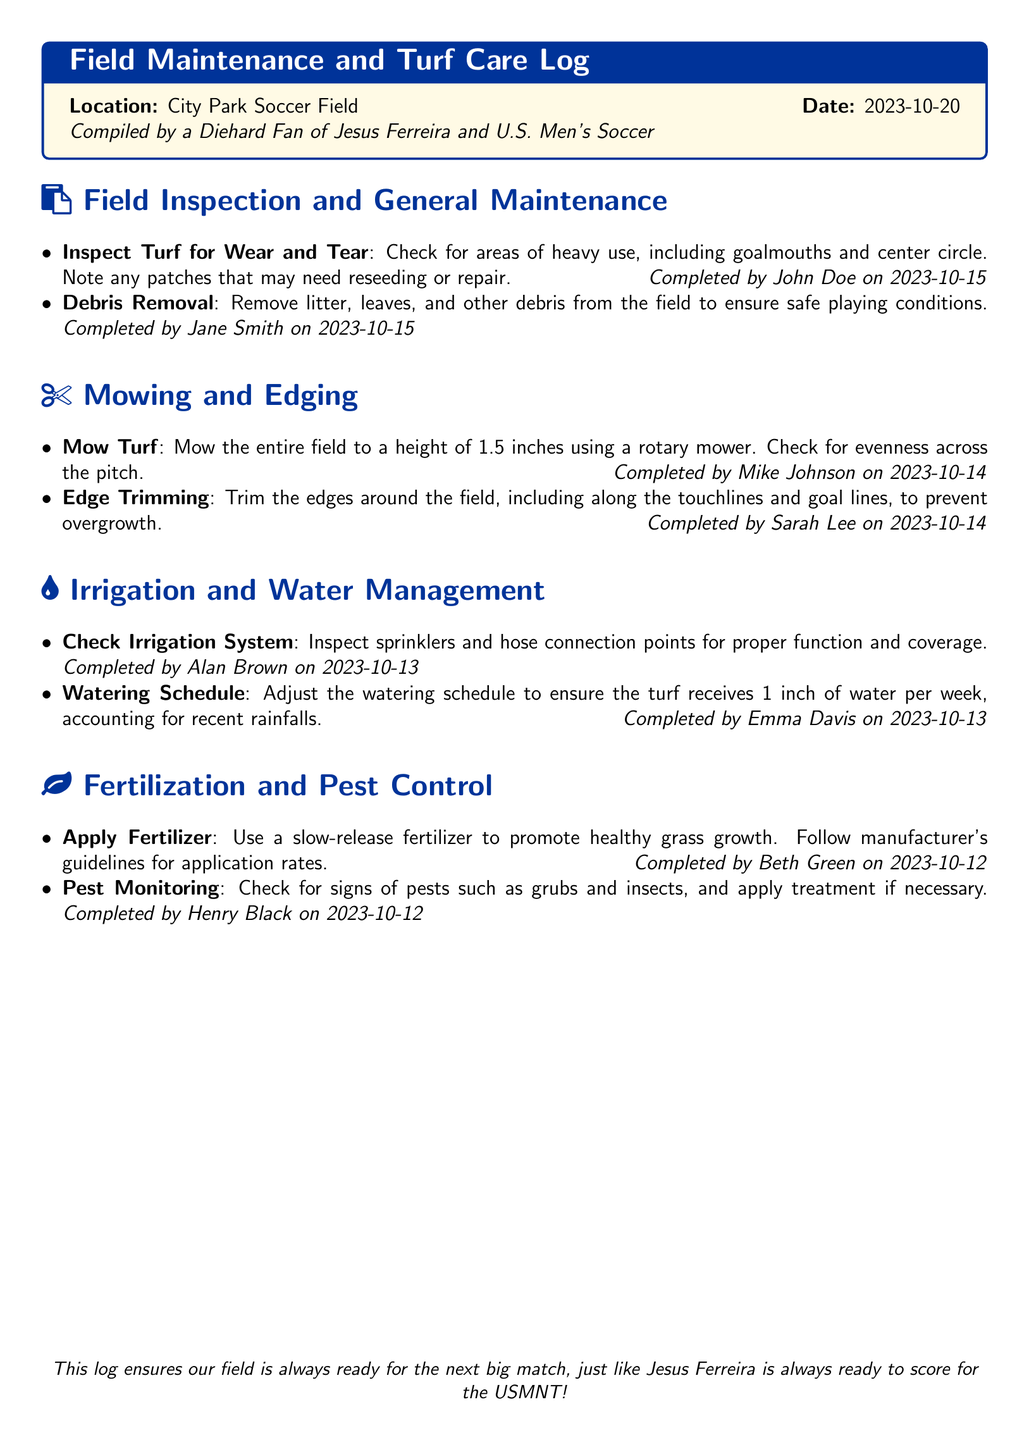What is the location of the soccer field? The location is stated at the top of the log, specifying where the maintenance activities take place.
Answer: City Park Soccer Field Who completed the irrigation system check? This log includes information about the person responsible for the irrigation system check on a specific date.
Answer: Alan Brown on 2023-10-13 What height was the turf mowed to? The mowing task specifies the desired height for the turf after mowing, which is mentioned in the maintenance entry.
Answer: 1.5 inches When was the fertilizer applied? The fertilization task indicates the date on which the application of fertilizer took place.
Answer: 2023-10-12 How many tasks were completed under field inspection? By analyzing the number of items listed under field inspection and general maintenance, this count can be determined.
Answer: 2 What task required trimming around the edges? This task is specifically outlined in the mowing and edging section of the document, indicating necessary maintenance to prevent overgrowth.
Answer: Edge Trimming What is the watering schedule adjustment to ensure? The watering schedule outlines how much water the turf should receive each week, which reflects the turf's needs.
Answer: 1 inch of water per week Who compiled the maintenance log? The log includes a note at the top about the individual responsible for compiling it, revealing their identity in the log.
Answer: A Diehard Fan of Jesus Ferreira and U.S. Men's Soccer 